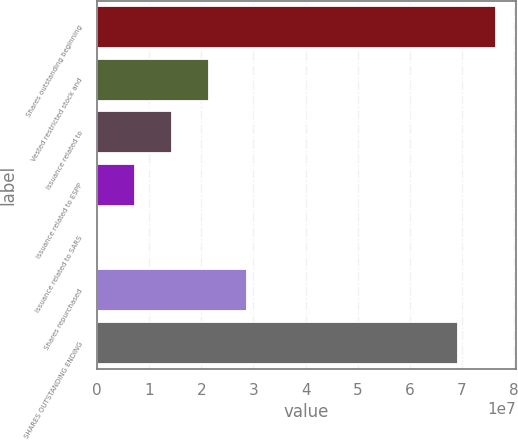<chart> <loc_0><loc_0><loc_500><loc_500><bar_chart><fcel>Shares outstanding beginning<fcel>Vested restricted stock and<fcel>Issuance related to<fcel>Issuance related to ESPP<fcel>Issuance related to SARS<fcel>Shares repurchased<fcel>SHARES OUTSTANDING ENDING<nl><fcel>7.64795e+07<fcel>2.15689e+07<fcel>1.4389e+07<fcel>7.20915e+06<fcel>29260<fcel>2.87488e+07<fcel>6.92996e+07<nl></chart> 